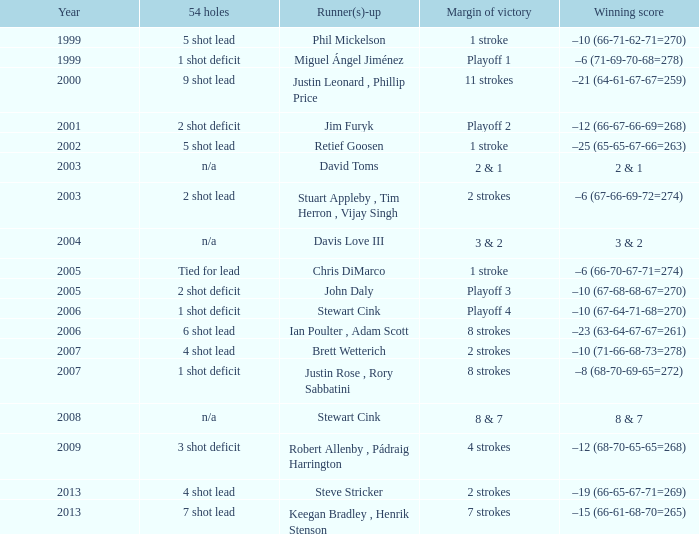In which year is the highest for runner-up Steve Stricker? 2013.0. 